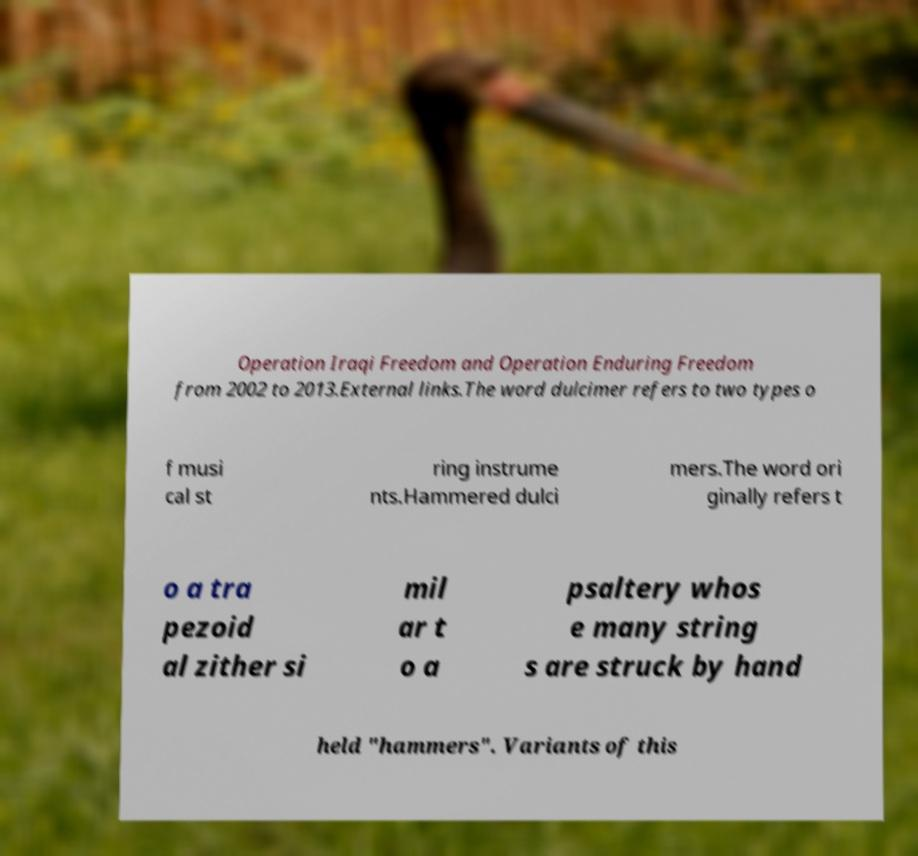There's text embedded in this image that I need extracted. Can you transcribe it verbatim? Operation Iraqi Freedom and Operation Enduring Freedom from 2002 to 2013.External links.The word dulcimer refers to two types o f musi cal st ring instrume nts.Hammered dulci mers.The word ori ginally refers t o a tra pezoid al zither si mil ar t o a psaltery whos e many string s are struck by hand held "hammers". Variants of this 